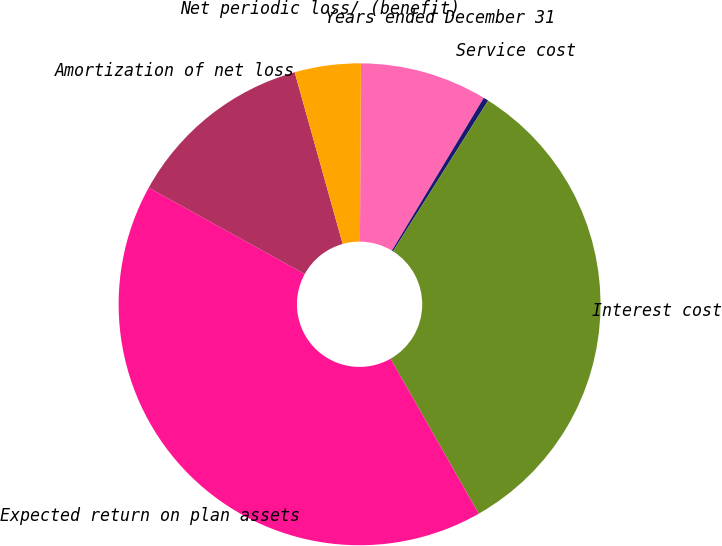Convert chart. <chart><loc_0><loc_0><loc_500><loc_500><pie_chart><fcel>Years ended December 31<fcel>Service cost<fcel>Interest cost<fcel>Expected return on plan assets<fcel>Amortization of net loss<fcel>Net periodic loss/ (benefit)<nl><fcel>8.53%<fcel>0.34%<fcel>32.8%<fcel>41.27%<fcel>12.62%<fcel>4.43%<nl></chart> 